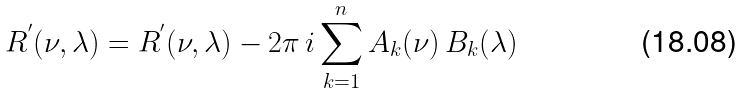Convert formula to latex. <formula><loc_0><loc_0><loc_500><loc_500>R ^ { ^ { \prime } } ( \nu , \lambda ) = R ^ { ^ { \prime } } ( \nu , \lambda ) - 2 \pi \, i \sum _ { k = 1 } ^ { n } A _ { k } ( \nu ) \, B _ { k } ( \lambda )</formula> 